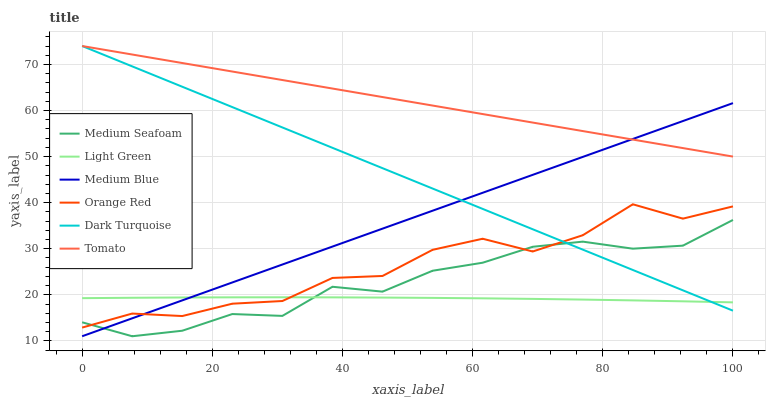Does Dark Turquoise have the minimum area under the curve?
Answer yes or no. No. Does Dark Turquoise have the maximum area under the curve?
Answer yes or no. No. Is Dark Turquoise the smoothest?
Answer yes or no. No. Is Dark Turquoise the roughest?
Answer yes or no. No. Does Dark Turquoise have the lowest value?
Answer yes or no. No. Does Medium Blue have the highest value?
Answer yes or no. No. Is Medium Seafoam less than Tomato?
Answer yes or no. Yes. Is Tomato greater than Orange Red?
Answer yes or no. Yes. Does Medium Seafoam intersect Tomato?
Answer yes or no. No. 